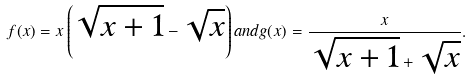<formula> <loc_0><loc_0><loc_500><loc_500>f ( x ) = x \left ( { \sqrt { x + 1 } } - { \sqrt { x } } \right ) { a n d } g ( x ) = { \frac { x } { { \sqrt { x + 1 } } + { \sqrt { x } } } } .</formula> 